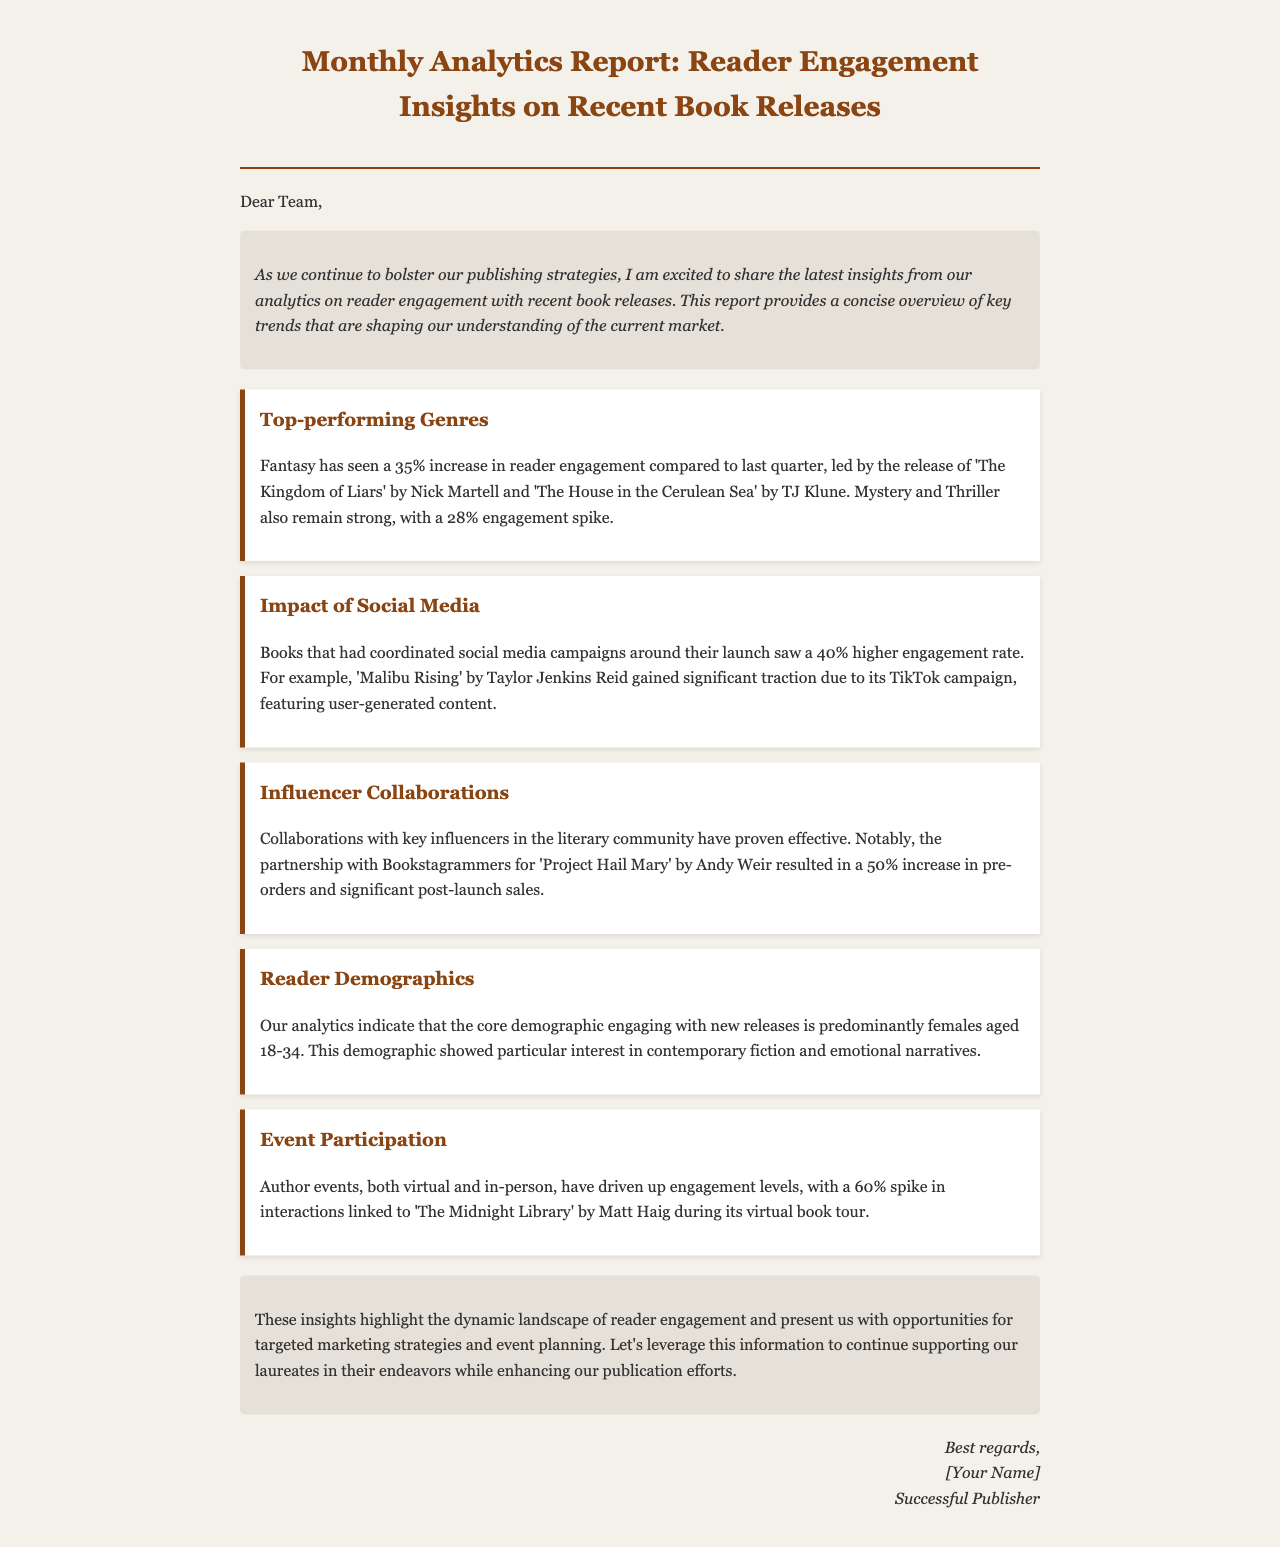What is the main purpose of the email? The email presents insights from analytics on reader engagement with recent book releases, aimed at informing strategies for publishing.
Answer: Publishing strategies What genre had a 35% increase in reader engagement? The document states that fantasy has seen a 35% increase in reader engagement.
Answer: Fantasy Which book was highlighted for its significant social media campaign? The report specifically mentions 'Malibu Rising' by Taylor Jenkins Reid for its TikTok campaign.
Answer: Malibu Rising What demographic predominantly engages with new releases? The analytics indicate that the core demographic engaging with new releases is predominantly females aged 18-34.
Answer: Females aged 18-34 What was the engagement increase linked to 'The Midnight Library'? Author events led to a 60% spike in interactions for 'The Midnight Library' during its virtual book tour.
Answer: 60% What is the engagement rate increase for books with social media campaigns? Books that had coordinated social media campaigns around their launch saw a 40% higher engagement rate.
Answer: 40% Which book's influencer collaboration resulted in a 50% increase in pre-orders? The partnership with Bookstagrammers for 'Project Hail Mary' by Andy Weir resulted in that significant increase.
Answer: Project Hail Mary What was the tone of the introduction paragraph? The introduction paragraph expresses excitement to share insights from analytics.
Answer: Excitement How did the email conclude? The conclusion highlights the dynamic landscape of reader engagement and opportunities for strategic marketing.
Answer: Strategic marketing 